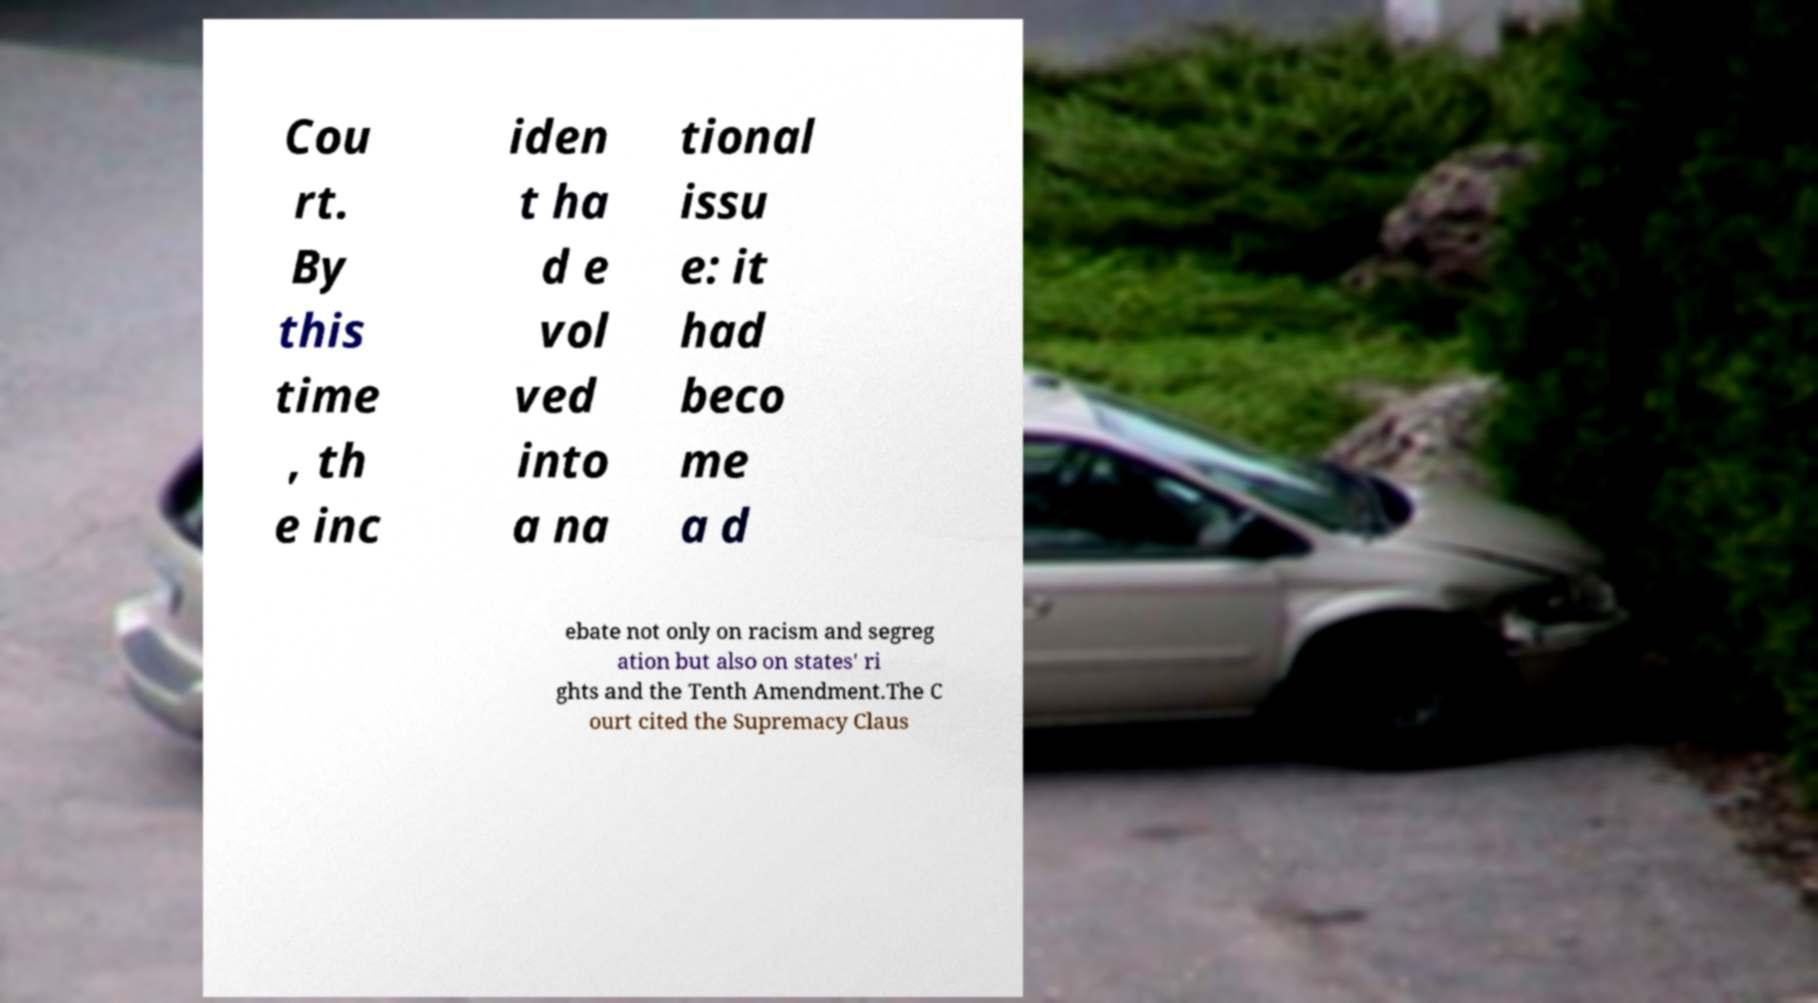Can you accurately transcribe the text from the provided image for me? Cou rt. By this time , th e inc iden t ha d e vol ved into a na tional issu e: it had beco me a d ebate not only on racism and segreg ation but also on states' ri ghts and the Tenth Amendment.The C ourt cited the Supremacy Claus 